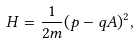Convert formula to latex. <formula><loc_0><loc_0><loc_500><loc_500>H = \frac { 1 } { 2 m } ( p - q A ) ^ { 2 } ,</formula> 